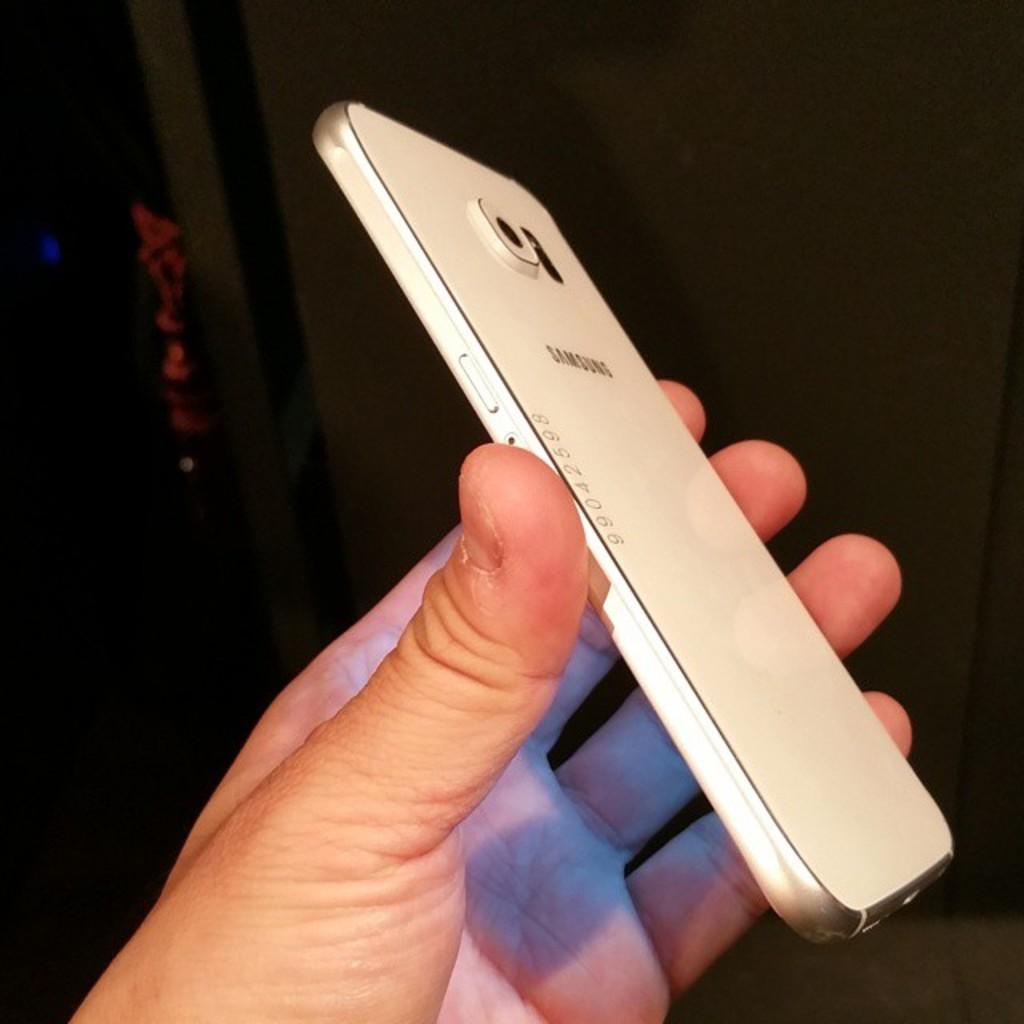What object is being held by a person in the image? There is a mobile phone in the image, and a person is holding it. What is the color of the mobile phone? The mobile phone is white in color. Can you describe the person holding the mobile phone? The provided facts do not give any information about the person holding the mobile phone. What type of polish is being applied to the mobile phone in the image? There is no indication in the image that any polish is being applied to the mobile phone. 